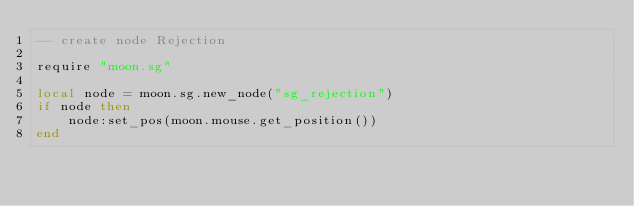Convert code to text. <code><loc_0><loc_0><loc_500><loc_500><_Lua_>-- create node Rejection

require "moon.sg"

local node = moon.sg.new_node("sg_rejection")
if node then
	node:set_pos(moon.mouse.get_position())
end</code> 